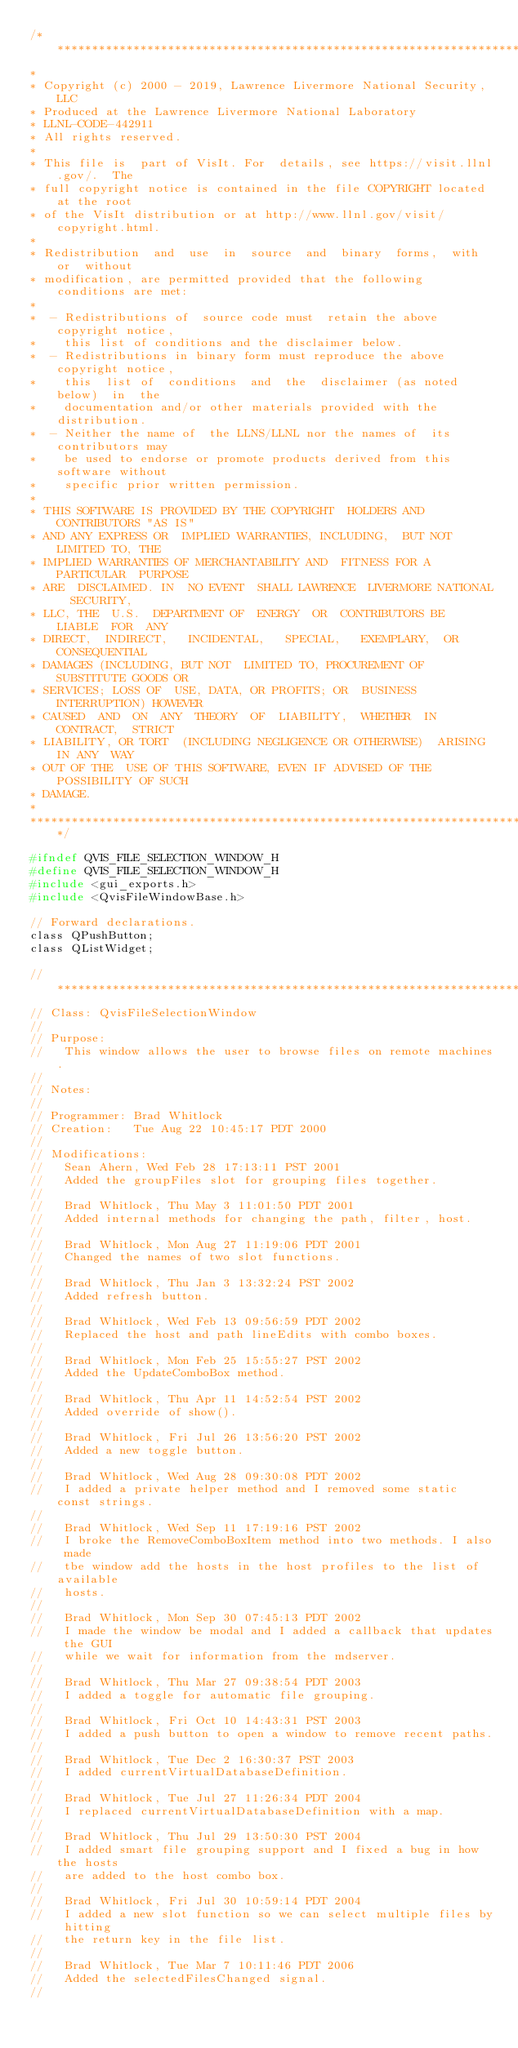Convert code to text. <code><loc_0><loc_0><loc_500><loc_500><_C_>/*****************************************************************************
*
* Copyright (c) 2000 - 2019, Lawrence Livermore National Security, LLC
* Produced at the Lawrence Livermore National Laboratory
* LLNL-CODE-442911
* All rights reserved.
*
* This file is  part of VisIt. For  details, see https://visit.llnl.gov/.  The
* full copyright notice is contained in the file COPYRIGHT located at the root
* of the VisIt distribution or at http://www.llnl.gov/visit/copyright.html.
*
* Redistribution  and  use  in  source  and  binary  forms,  with  or  without
* modification, are permitted provided that the following conditions are met:
*
*  - Redistributions of  source code must  retain the above  copyright notice,
*    this list of conditions and the disclaimer below.
*  - Redistributions in binary form must reproduce the above copyright notice,
*    this  list of  conditions  and  the  disclaimer (as noted below)  in  the
*    documentation and/or other materials provided with the distribution.
*  - Neither the name of  the LLNS/LLNL nor the names of  its contributors may
*    be used to endorse or promote products derived from this software without
*    specific prior written permission.
*
* THIS SOFTWARE IS PROVIDED BY THE COPYRIGHT  HOLDERS AND CONTRIBUTORS "AS IS"
* AND ANY EXPRESS OR  IMPLIED WARRANTIES, INCLUDING,  BUT NOT  LIMITED TO, THE
* IMPLIED WARRANTIES OF MERCHANTABILITY AND  FITNESS FOR A PARTICULAR  PURPOSE
* ARE  DISCLAIMED. IN  NO EVENT  SHALL LAWRENCE  LIVERMORE NATIONAL  SECURITY,
* LLC, THE  U.S.  DEPARTMENT OF  ENERGY  OR  CONTRIBUTORS BE  LIABLE  FOR  ANY
* DIRECT,  INDIRECT,   INCIDENTAL,   SPECIAL,   EXEMPLARY,  OR   CONSEQUENTIAL
* DAMAGES (INCLUDING, BUT NOT  LIMITED TO, PROCUREMENT OF  SUBSTITUTE GOODS OR
* SERVICES; LOSS OF  USE, DATA, OR PROFITS; OR  BUSINESS INTERRUPTION) HOWEVER
* CAUSED  AND  ON  ANY  THEORY  OF  LIABILITY,  WHETHER  IN  CONTRACT,  STRICT
* LIABILITY, OR TORT  (INCLUDING NEGLIGENCE OR OTHERWISE)  ARISING IN ANY  WAY
* OUT OF THE  USE OF THIS SOFTWARE, EVEN IF ADVISED OF THE POSSIBILITY OF SUCH
* DAMAGE.
*
*****************************************************************************/

#ifndef QVIS_FILE_SELECTION_WINDOW_H
#define QVIS_FILE_SELECTION_WINDOW_H
#include <gui_exports.h>
#include <QvisFileWindowBase.h>

// Forward declarations.
class QPushButton;
class QListWidget;

// ****************************************************************************
// Class: QvisFileSelectionWindow
//
// Purpose:
//   This window allows the user to browse files on remote machines.
//
// Notes:      
//
// Programmer: Brad Whitlock
// Creation:   Tue Aug 22 10:45:17 PDT 2000
//
// Modifications:
//   Sean Ahern, Wed Feb 28 17:13:11 PST 2001
//   Added the groupFiles slot for grouping files together.
//
//   Brad Whitlock, Thu May 3 11:01:50 PDT 2001
//   Added internal methods for changing the path, filter, host.
//
//   Brad Whitlock, Mon Aug 27 11:19:06 PDT 2001
//   Changed the names of two slot functions.
//
//   Brad Whitlock, Thu Jan 3 13:32:24 PST 2002
//   Added refresh button.
//
//   Brad Whitlock, Wed Feb 13 09:56:59 PDT 2002
//   Replaced the host and path lineEdits with combo boxes.
//
//   Brad Whitlock, Mon Feb 25 15:55:27 PST 2002
//   Added the UpdateComboBox method.
//
//   Brad Whitlock, Thu Apr 11 14:52:54 PST 2002
//   Added override of show().
//
//   Brad Whitlock, Fri Jul 26 13:56:20 PST 2002
//   Added a new toggle button.
//
//   Brad Whitlock, Wed Aug 28 09:30:08 PDT 2002
//   I added a private helper method and I removed some static const strings.
//
//   Brad Whitlock, Wed Sep 11 17:19:16 PST 2002
//   I broke the RemoveComboBoxItem method into two methods. I also made
//   tbe window add the hosts in the host profiles to the list of available
//   hosts.
//
//   Brad Whitlock, Mon Sep 30 07:45:13 PDT 2002
//   I made the window be modal and I added a callback that updates the GUI
//   while we wait for information from the mdserver.
//
//   Brad Whitlock, Thu Mar 27 09:38:54 PDT 2003
//   I added a toggle for automatic file grouping.
//
//   Brad Whitlock, Fri Oct 10 14:43:31 PST 2003
//   I added a push button to open a window to remove recent paths.
//
//   Brad Whitlock, Tue Dec 2 16:30:37 PST 2003
//   I added currentVirtualDatabaseDefinition.
//
//   Brad Whitlock, Tue Jul 27 11:26:34 PDT 2004
//   I replaced currentVirtualDatabaseDefinition with a map.
//
//   Brad Whitlock, Thu Jul 29 13:50:30 PST 2004
//   I added smart file grouping support and I fixed a bug in how the hosts
//   are added to the host combo box.
//
//   Brad Whitlock, Fri Jul 30 10:59:14 PDT 2004
//   I added a new slot function so we can select multiple files by hitting
//   the return key in the file list.
//
//   Brad Whitlock, Tue Mar 7 10:11:46 PDT 2006
//   Added the selectedFilesChanged signal.
//</code> 